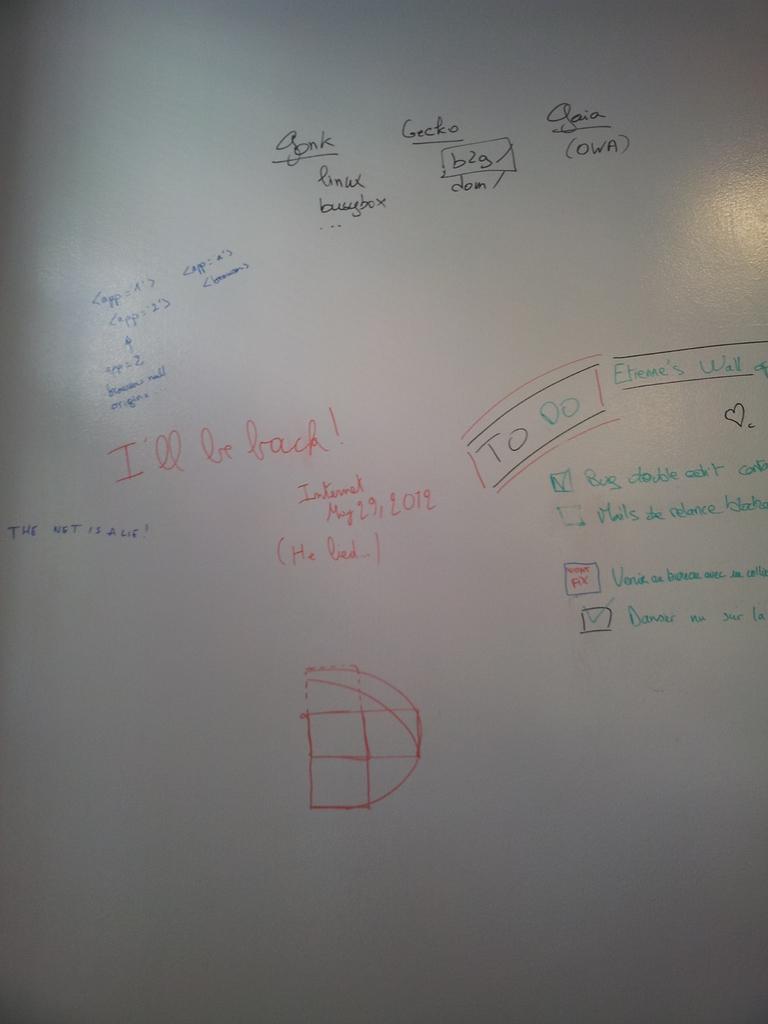What type of list is on the right side of the whiteboard?
Offer a terse response. To do. What's the date?
Provide a succinct answer. May 29, 2012. 